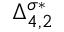Convert formula to latex. <formula><loc_0><loc_0><loc_500><loc_500>\Delta _ { 4 , 2 } ^ { \sigma * }</formula> 